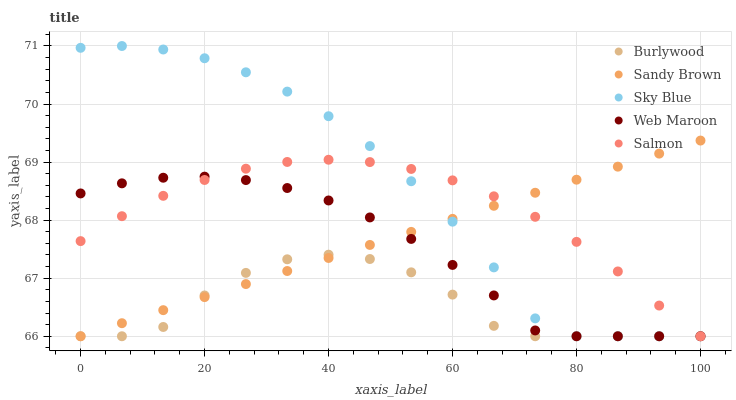Does Burlywood have the minimum area under the curve?
Answer yes or no. Yes. Does Sky Blue have the maximum area under the curve?
Answer yes or no. Yes. Does Sandy Brown have the minimum area under the curve?
Answer yes or no. No. Does Sandy Brown have the maximum area under the curve?
Answer yes or no. No. Is Sandy Brown the smoothest?
Answer yes or no. Yes. Is Burlywood the roughest?
Answer yes or no. Yes. Is Sky Blue the smoothest?
Answer yes or no. No. Is Sky Blue the roughest?
Answer yes or no. No. Does Burlywood have the lowest value?
Answer yes or no. Yes. Does Sky Blue have the highest value?
Answer yes or no. Yes. Does Sandy Brown have the highest value?
Answer yes or no. No. Does Burlywood intersect Web Maroon?
Answer yes or no. Yes. Is Burlywood less than Web Maroon?
Answer yes or no. No. Is Burlywood greater than Web Maroon?
Answer yes or no. No. 